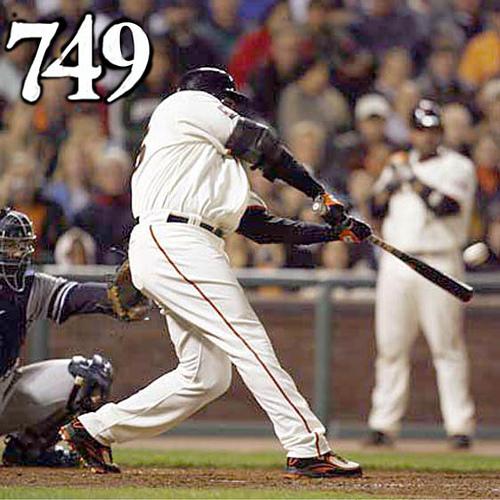What color is the baseball bat?
Keep it brief. Black. What number is written on the picture?
Quick response, please. 749. Who is the batter?
Be succinct. David ortiz. Did the batter hit the ball?
Give a very brief answer. Yes. 